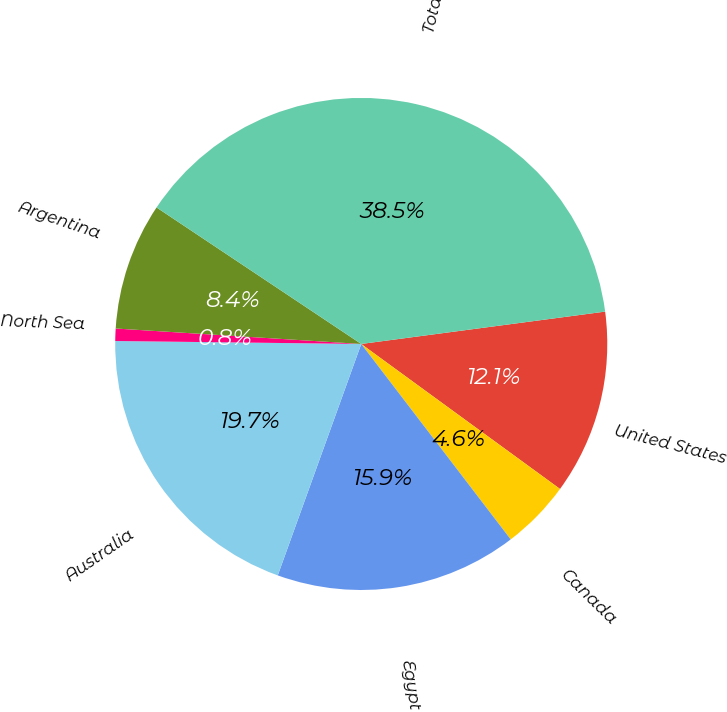Convert chart to OTSL. <chart><loc_0><loc_0><loc_500><loc_500><pie_chart><fcel>United States<fcel>Canada<fcel>Egypt<fcel>Australia<fcel>North Sea<fcel>Argentina<fcel>Total<nl><fcel>12.13%<fcel>4.58%<fcel>15.9%<fcel>19.68%<fcel>0.81%<fcel>8.36%<fcel>38.54%<nl></chart> 